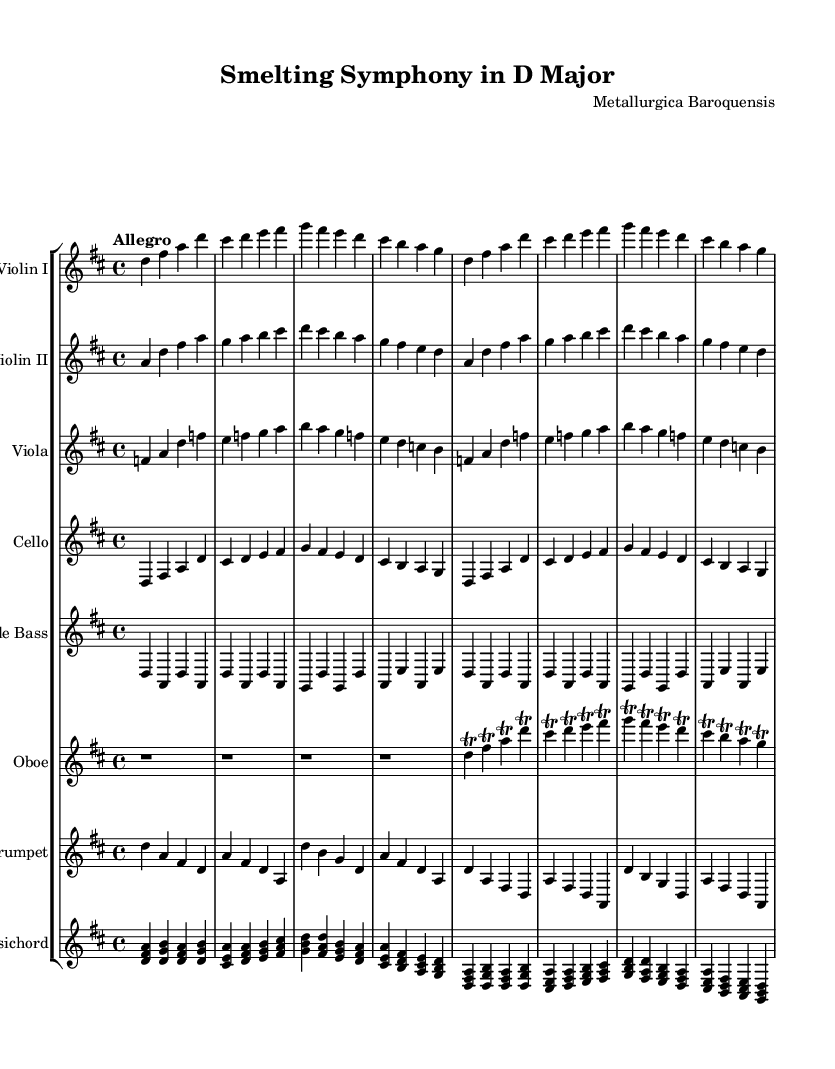What is the key signature of this music? The key signature is indicated at the beginning of the score. It shows two sharps, which corresponds to D major.
Answer: D major What is the time signature of this music? The time signature is shown on the staff near the beginning and is written as 4/4, indicating four beats per measure.
Answer: 4/4 What is the tempo marking of this piece? The tempo indication at the beginning states "Allegro," which means fast, lively, and cheerful.
Answer: Allegro Which instruments are featured in this orchestral piece? The sheet music lists multiple staves for different instruments: Violin I, Violin II, Viola, Cello, Double Bass, Oboe, Trumpet, and Harpsichord.
Answer: Violin I, Violin II, Viola, Cello, Double Bass, Oboe, Trumpet, Harpsichord What is a prominent feature of the oboe part in this piece? The oboe part contains several trills, indicated by the trill markings next to the note letters, which add ornamentation typical of Baroque music.
Answer: Trills How many measures are present in the provided sections? By counting the measures in each instrumental part as we go through the music, there are a total of 8 measures presented for each string instrument.
Answer: 8 measures 